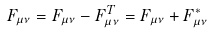Convert formula to latex. <formula><loc_0><loc_0><loc_500><loc_500>\ F _ { \mu \nu } = F _ { \mu \nu } - F _ { \mu \nu } ^ { T } = F _ { \mu \nu } + F _ { \mu \nu } ^ { * }</formula> 